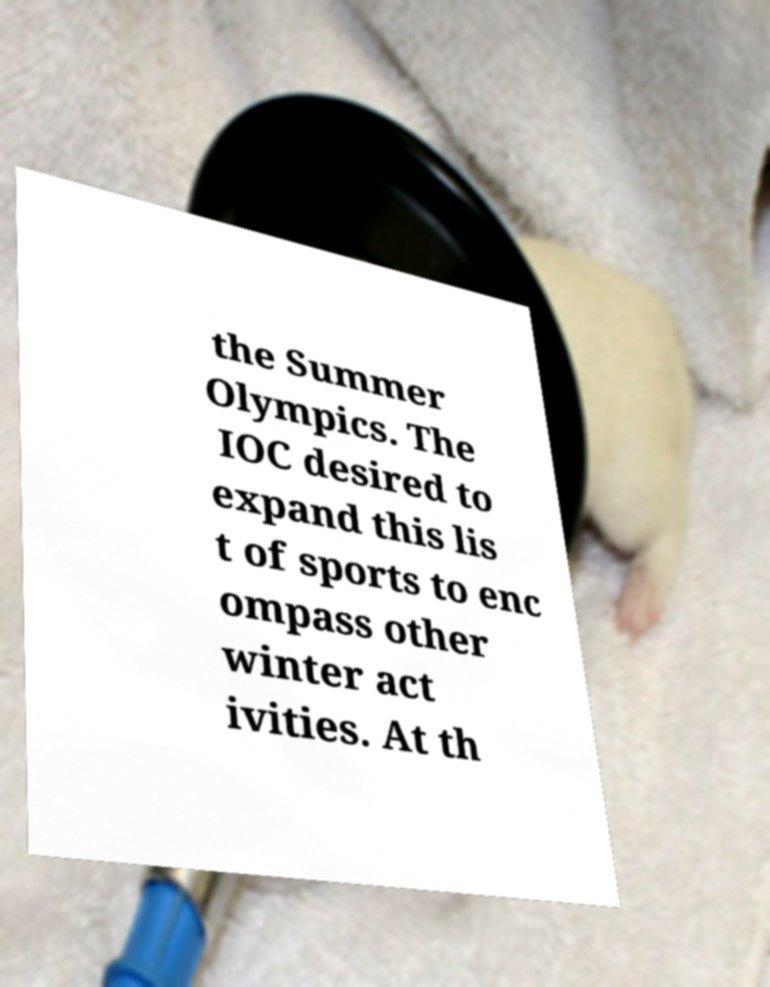Please identify and transcribe the text found in this image. the Summer Olympics. The IOC desired to expand this lis t of sports to enc ompass other winter act ivities. At th 